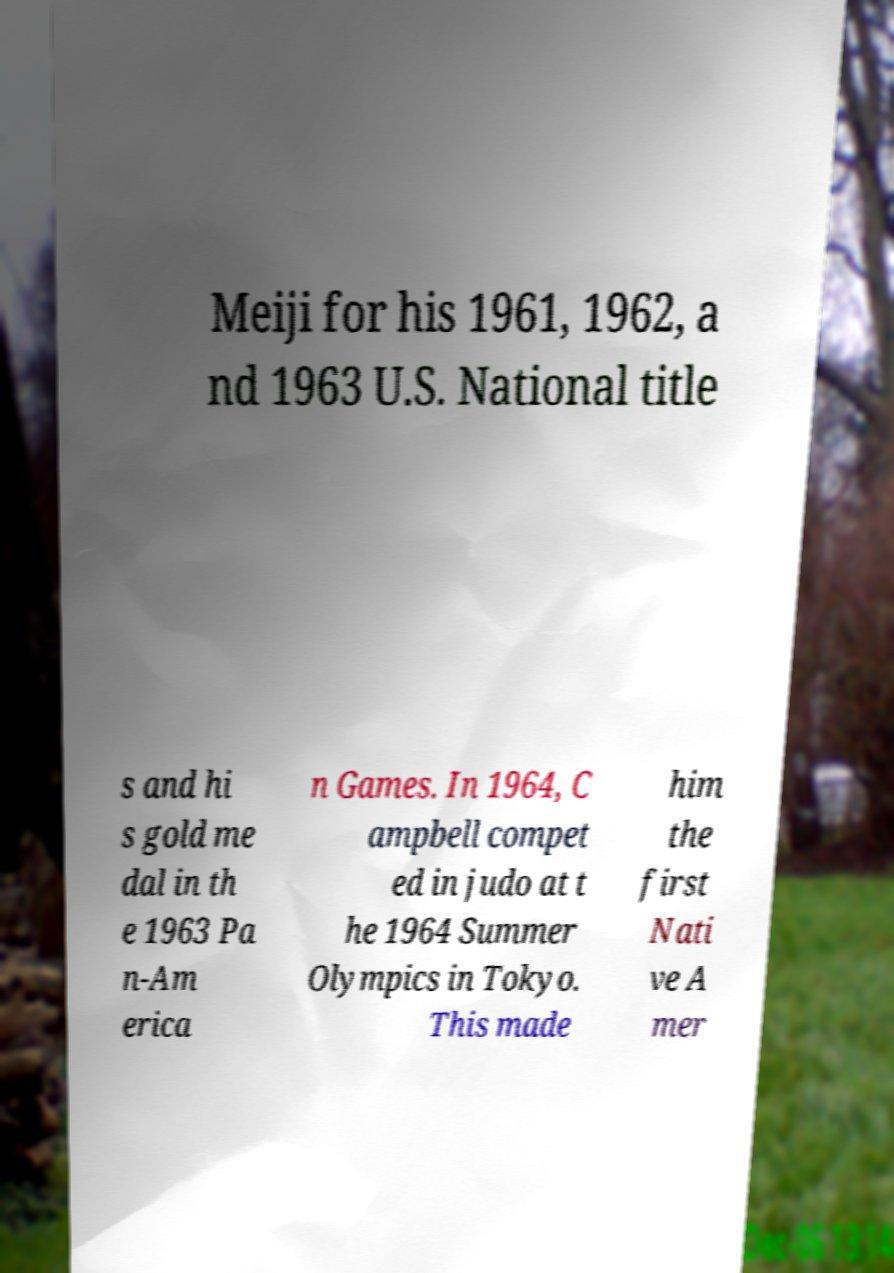Can you accurately transcribe the text from the provided image for me? Meiji for his 1961, 1962, a nd 1963 U.S. National title s and hi s gold me dal in th e 1963 Pa n-Am erica n Games. In 1964, C ampbell compet ed in judo at t he 1964 Summer Olympics in Tokyo. This made him the first Nati ve A mer 